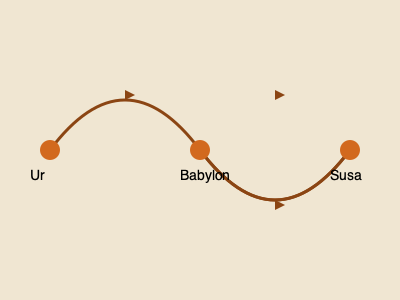Based on the trade route map of ancient Mesopotamia, which city appears to be the central hub for trade, potentially acting as an intermediary between Ur and Susa? To answer this question, let's analyze the trade route map step-by-step:

1. The map shows three major cities: Ur, Babylon, and Susa.

2. There are two main trade routes depicted:
   a. A northern route connecting Ur to Babylon to Susa
   b. A southern route connecting Babylon directly to Susa

3. Ur is located on the western end of the map, while Susa is on the eastern end.

4. Babylon is positioned in the center of the map, with trade routes connecting it to both Ur and Susa.

5. The presence of both northern and southern routes passing through Babylon indicates that it serves as a connection point between Ur and Susa.

6. The central location of Babylon on the map, combined with its connections to both other cities, suggests that it likely played a crucial role in facilitating trade between Ur and Susa.

7. This central position would have allowed Babylon to act as an intermediary, potentially controlling or influencing the flow of goods between the other two cities.

Given these observations, Babylon appears to be the central hub for trade in this network, strategically positioned to mediate commerce between Ur and Susa.
Answer: Babylon 